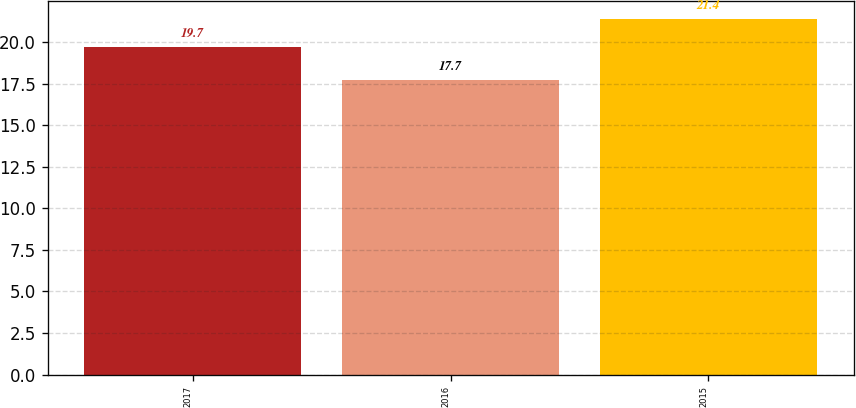<chart> <loc_0><loc_0><loc_500><loc_500><bar_chart><fcel>2017<fcel>2016<fcel>2015<nl><fcel>19.7<fcel>17.7<fcel>21.4<nl></chart> 